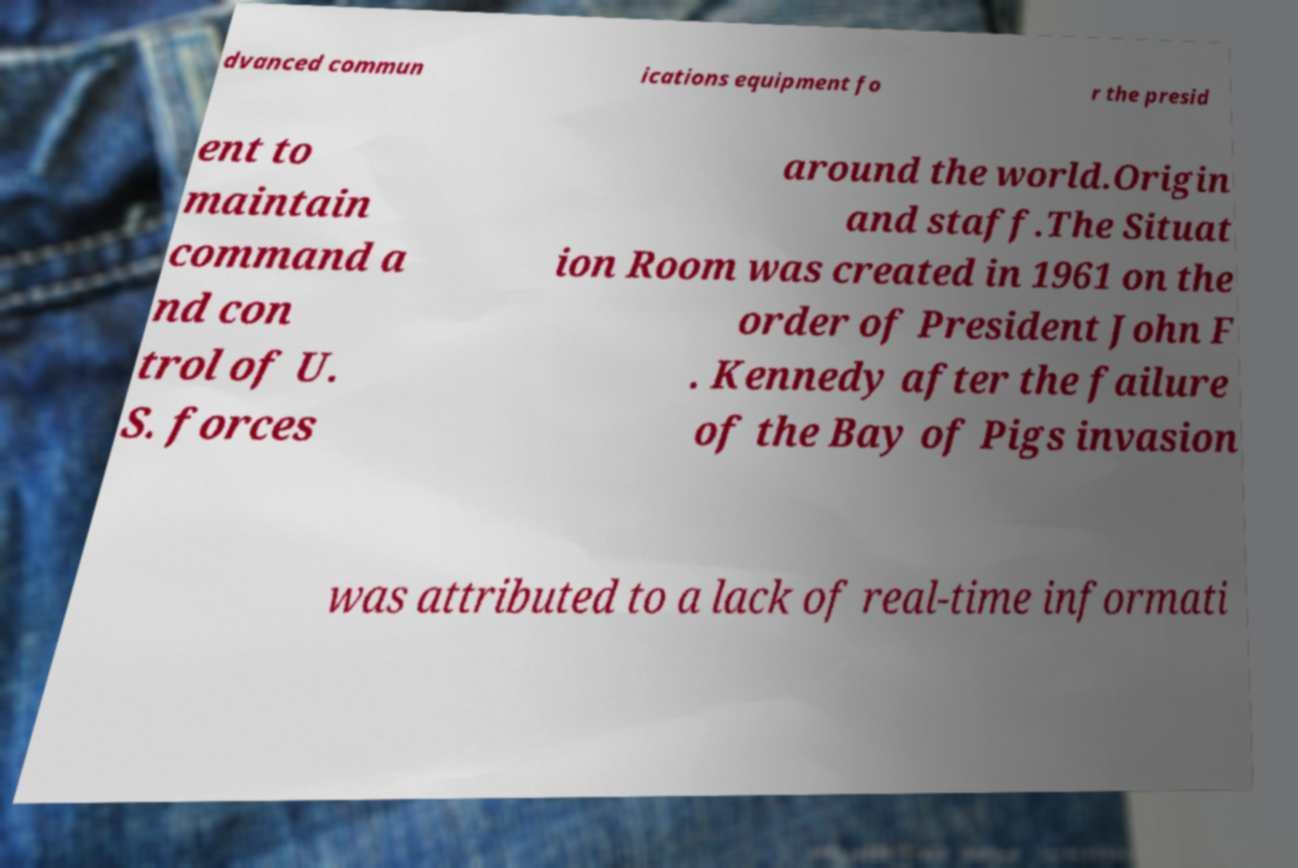Can you accurately transcribe the text from the provided image for me? dvanced commun ications equipment fo r the presid ent to maintain command a nd con trol of U. S. forces around the world.Origin and staff.The Situat ion Room was created in 1961 on the order of President John F . Kennedy after the failure of the Bay of Pigs invasion was attributed to a lack of real-time informati 